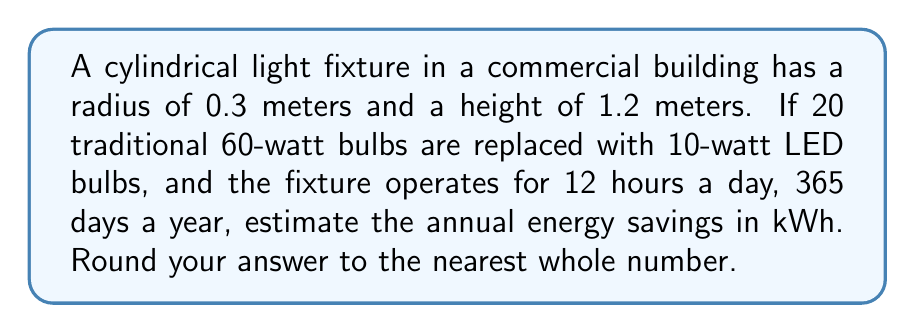Provide a solution to this math problem. To solve this problem, we'll follow these steps:

1. Calculate the power difference between traditional and LED bulbs:
   Power difference = (60 W - 10 W) × 20 bulbs = 1000 W = 1 kW

2. Calculate the daily operation time:
   Daily operation = 12 hours

3. Calculate the annual operation time:
   Annual operation = 12 hours × 365 days = 4380 hours

4. Calculate the annual energy savings:
   $$\text{Energy savings} = \text{Power difference} \times \text{Annual operation time}$$
   $$\text{Energy savings} = 1 \text{ kW} \times 4380 \text{ hours} = 4380 \text{ kWh}$$

5. Round the result to the nearest whole number:
   4380 kWh (no rounding needed)

Note: The cylindrical dimensions of the fixture weren't necessary for this calculation but provide context for the marketing manager to visualize the scenario.
Answer: 4380 kWh 